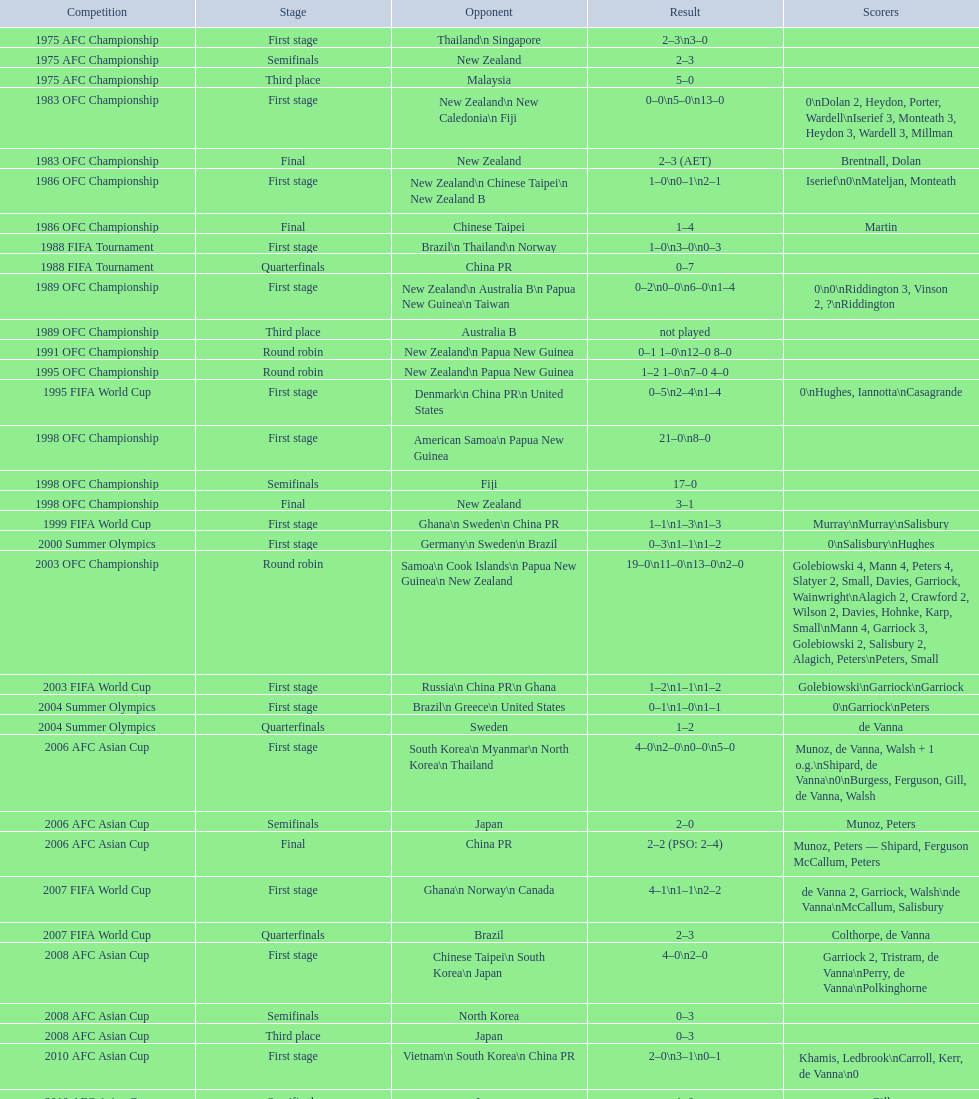What is the discrepancy in the total goals scored between the 1999 fifa world cup and the 2000 summer olympics? 2. 